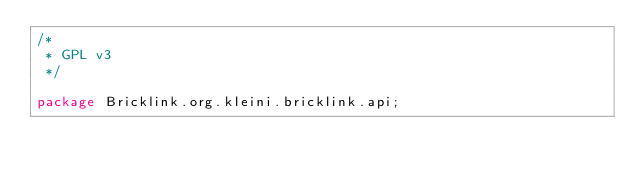Convert code to text. <code><loc_0><loc_0><loc_500><loc_500><_Java_>/*
 * GPL v3
 */

package Bricklink.org.kleini.bricklink.api;
</code> 